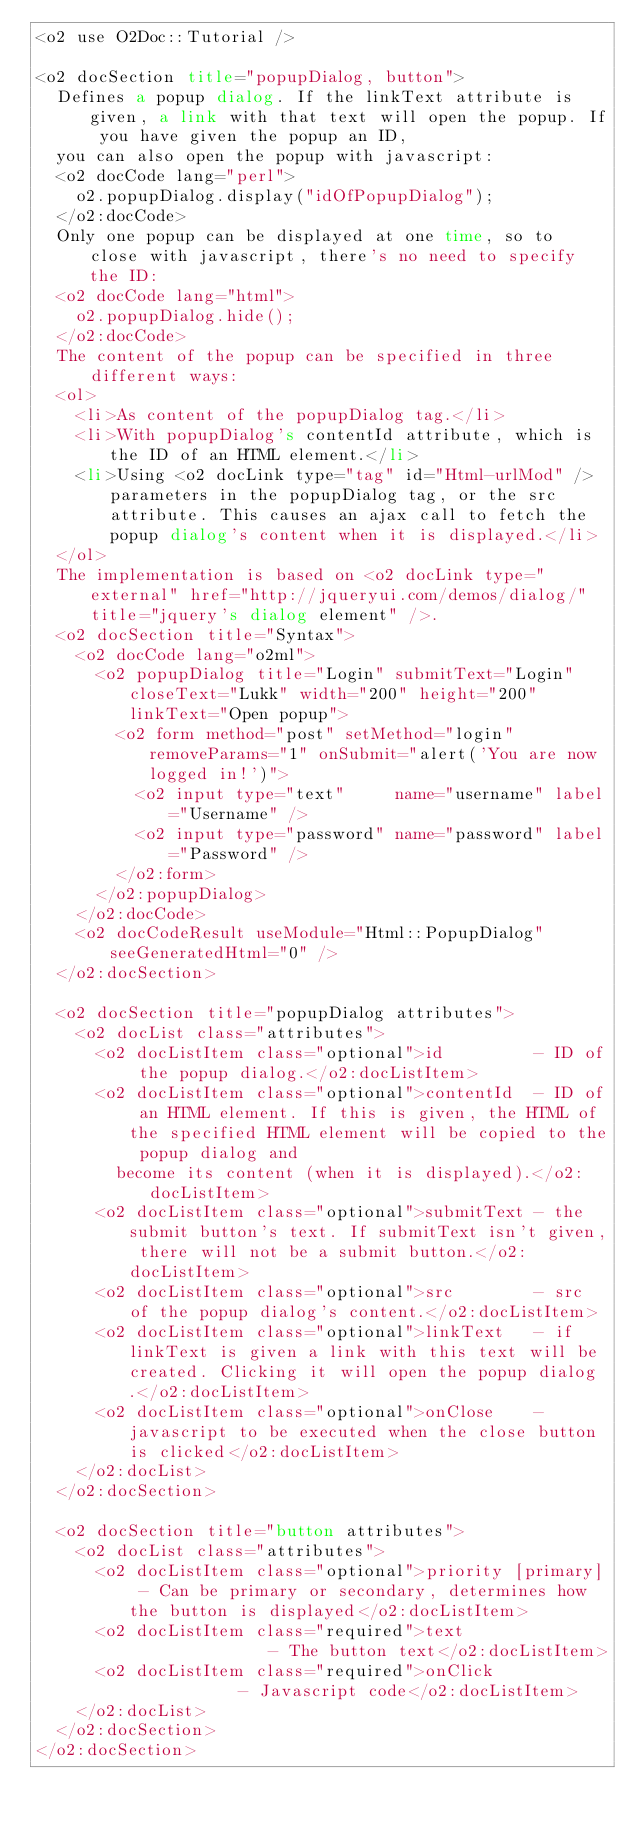Convert code to text. <code><loc_0><loc_0><loc_500><loc_500><_HTML_><o2 use O2Doc::Tutorial />

<o2 docSection title="popupDialog, button">
  Defines a popup dialog. If the linkText attribute is given, a link with that text will open the popup. If you have given the popup an ID,
  you can also open the popup with javascript:
  <o2 docCode lang="perl">
    o2.popupDialog.display("idOfPopupDialog");
  </o2:docCode>
  Only one popup can be displayed at one time, so to close with javascript, there's no need to specify the ID:
  <o2 docCode lang="html">
    o2.popupDialog.hide();
  </o2:docCode>
  The content of the popup can be specified in three different ways:
  <ol>
    <li>As content of the popupDialog tag.</li>
    <li>With popupDialog's contentId attribute, which is the ID of an HTML element.</li>
    <li>Using <o2 docLink type="tag" id="Html-urlMod" /> parameters in the popupDialog tag, or the src attribute. This causes an ajax call to fetch the popup dialog's content when it is displayed.</li>
  </ol>
  The implementation is based on <o2 docLink type="external" href="http://jqueryui.com/demos/dialog/" title="jquery's dialog element" />.
  <o2 docSection title="Syntax">
    <o2 docCode lang="o2ml">
      <o2 popupDialog title="Login" submitText="Login" closeText="Lukk" width="200" height="200" linkText="Open popup">
        <o2 form method="post" setMethod="login" removeParams="1" onSubmit="alert('You are now logged in!')">
          <o2 input type="text"     name="username" label="Username" />
          <o2 input type="password" name="password" label="Password" />
        </o2:form>
      </o2:popupDialog>
    </o2:docCode>
    <o2 docCodeResult useModule="Html::PopupDialog" seeGeneratedHtml="0" />
  </o2:docSection>
  
  <o2 docSection title="popupDialog attributes">
    <o2 docList class="attributes">
      <o2 docListItem class="optional">id         - ID of the popup dialog.</o2:docListItem>
      <o2 docListItem class="optional">contentId  - ID of an HTML element. If this is given, the HTML of the specified HTML element will be copied to the popup dialog and
        become its content (when it is displayed).</o2:docListItem>
      <o2 docListItem class="optional">submitText - the submit button's text. If submitText isn't given, there will not be a submit button.</o2:docListItem>
      <o2 docListItem class="optional">src        - src of the popup dialog's content.</o2:docListItem>
      <o2 docListItem class="optional">linkText   - if linkText is given a link with this text will be created. Clicking it will open the popup dialog.</o2:docListItem>
      <o2 docListItem class="optional">onClose    - javascript to be executed when the close button is clicked</o2:docListItem>
    </o2:docList>
  </o2:docSection>
  
  <o2 docSection title="button attributes">
    <o2 docList class="attributes">
      <o2 docListItem class="optional">priority [primary] - Can be primary or secondary, determines how the button is displayed</o2:docListItem>
      <o2 docListItem class="required">text               - The button text</o2:docListItem>
      <o2 docListItem class="required">onClick            - Javascript code</o2:docListItem>
    </o2:docList>
  </o2:docSection>
</o2:docSection>
</code> 